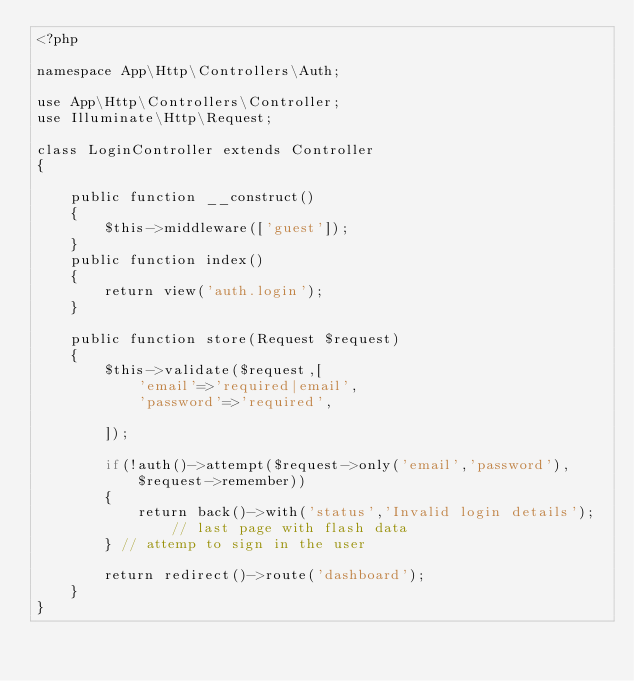Convert code to text. <code><loc_0><loc_0><loc_500><loc_500><_PHP_><?php

namespace App\Http\Controllers\Auth;

use App\Http\Controllers\Controller;
use Illuminate\Http\Request;

class LoginController extends Controller
{

    public function __construct()
    {
        $this->middleware(['guest']);
    }
    public function index()
    {
        return view('auth.login');
    }

    public function store(Request $request)
    {
        $this->validate($request,[ 
            'email'=>'required|email',
            'password'=>'required',
            
        ]);

        if(!auth()->attempt($request->only('email','password'),$request->remember))
        {
            return back()->with('status','Invalid login details'); // last page with flash data
        } // attemp to sign in the user

        return redirect()->route('dashboard');
    }
}
</code> 